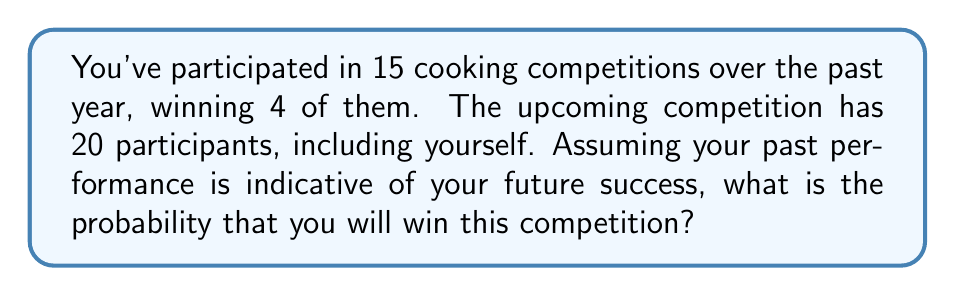Solve this math problem. To solve this problem, we need to use the concept of probability based on historical data. Let's break it down step-by-step:

1. Calculate your win rate from past competitions:
   $$ \text{Win rate} = \frac{\text{Number of wins}}{\text{Total competitions}} = \frac{4}{15} $$

2. Convert the win rate to a percentage:
   $$ \text{Win rate percentage} = \frac{4}{15} \times 100\% \approx 26.67\% $$

3. Now, we need to consider that there are 20 participants in the upcoming competition. If all participants were equally likely to win, each would have a 5% chance (1/20). However, we know your historical performance is better than that.

4. To calculate your probability of winning, we can use your historical win rate as your personal odds:
   $$ P(\text{winning}) = \frac{4/15}{20} = \frac{4}{15 \times 20} = \frac{1}{75} $$

5. Convert this probability to a percentage:
   $$ P(\text{winning}) = \frac{1}{75} \times 100\% \approx 1.33\% $$

This result shows that based on your historical performance, you have approximately a 1.33% chance of winning the upcoming competition. While this may seem low, it's important to note that it's still higher than the 5% (1/20) chance if all participants were equally likely to win.
Answer: $\frac{1}{75}$ or approximately $1.33\%$ 